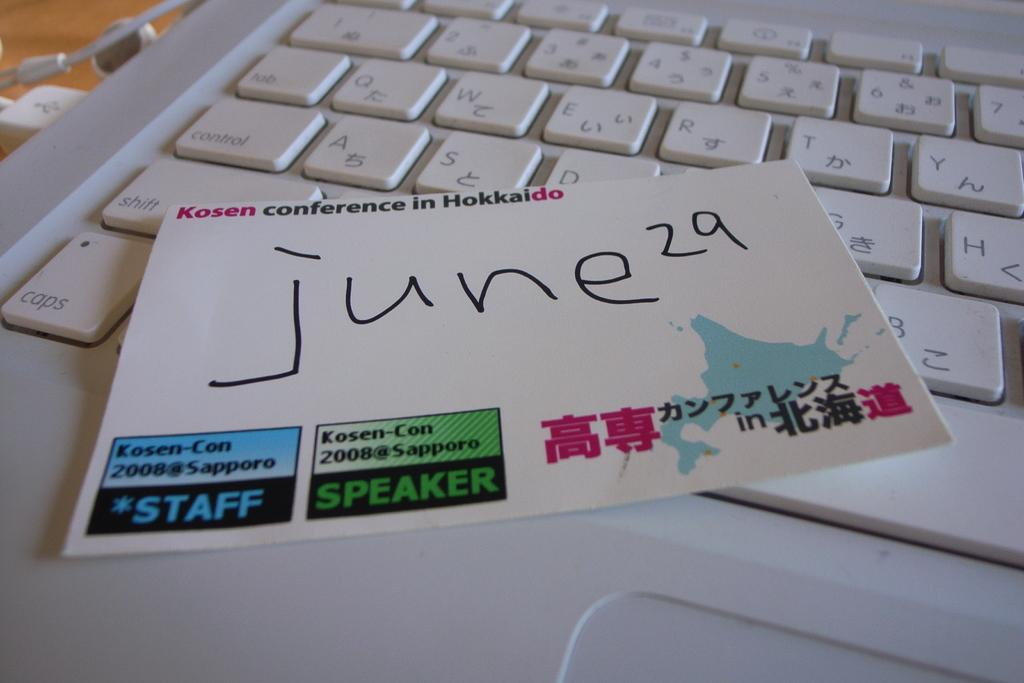<image>
Give a short and clear explanation of the subsequent image. A card on top of a keyboard with the date june 29 